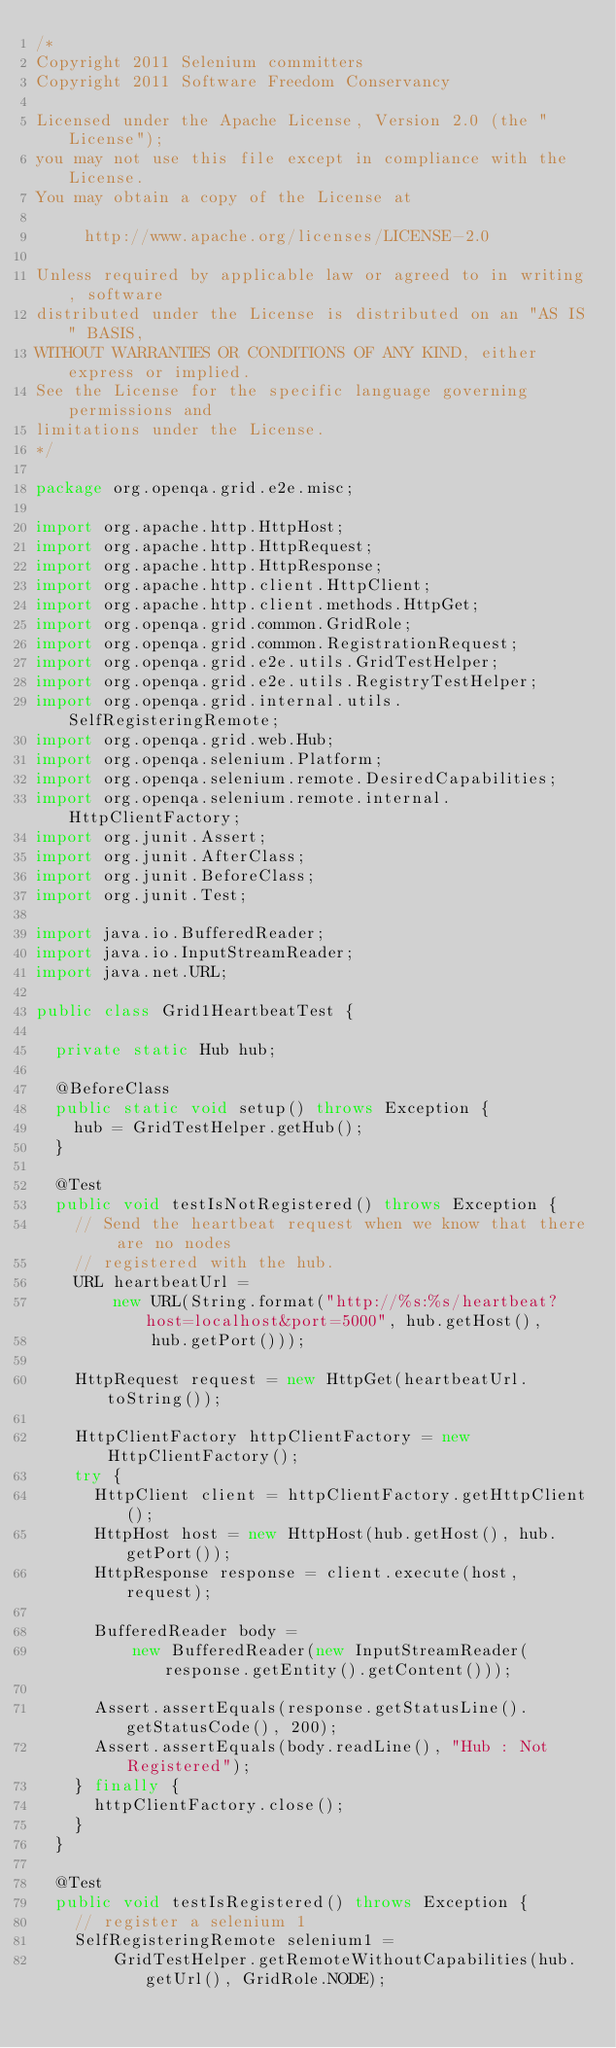Convert code to text. <code><loc_0><loc_0><loc_500><loc_500><_Java_>/*
Copyright 2011 Selenium committers
Copyright 2011 Software Freedom Conservancy

Licensed under the Apache License, Version 2.0 (the "License");
you may not use this file except in compliance with the License.
You may obtain a copy of the License at

     http://www.apache.org/licenses/LICENSE-2.0

Unless required by applicable law or agreed to in writing, software
distributed under the License is distributed on an "AS IS" BASIS,
WITHOUT WARRANTIES OR CONDITIONS OF ANY KIND, either express or implied.
See the License for the specific language governing permissions and
limitations under the License.
*/

package org.openqa.grid.e2e.misc;

import org.apache.http.HttpHost;
import org.apache.http.HttpRequest;
import org.apache.http.HttpResponse;
import org.apache.http.client.HttpClient;
import org.apache.http.client.methods.HttpGet;
import org.openqa.grid.common.GridRole;
import org.openqa.grid.common.RegistrationRequest;
import org.openqa.grid.e2e.utils.GridTestHelper;
import org.openqa.grid.e2e.utils.RegistryTestHelper;
import org.openqa.grid.internal.utils.SelfRegisteringRemote;
import org.openqa.grid.web.Hub;
import org.openqa.selenium.Platform;
import org.openqa.selenium.remote.DesiredCapabilities;
import org.openqa.selenium.remote.internal.HttpClientFactory;
import org.junit.Assert;
import org.junit.AfterClass;
import org.junit.BeforeClass;
import org.junit.Test;

import java.io.BufferedReader;
import java.io.InputStreamReader;
import java.net.URL;

public class Grid1HeartbeatTest {

  private static Hub hub;

  @BeforeClass
  public static void setup() throws Exception {
    hub = GridTestHelper.getHub();
  }

  @Test
  public void testIsNotRegistered() throws Exception {
    // Send the heartbeat request when we know that there are no nodes
    // registered with the hub.
    URL heartbeatUrl =
        new URL(String.format("http://%s:%s/heartbeat?host=localhost&port=5000", hub.getHost(),
            hub.getPort()));

    HttpRequest request = new HttpGet(heartbeatUrl.toString());

    HttpClientFactory httpClientFactory = new HttpClientFactory();
    try {
      HttpClient client = httpClientFactory.getHttpClient();
      HttpHost host = new HttpHost(hub.getHost(), hub.getPort());
      HttpResponse response = client.execute(host, request);

      BufferedReader body =
          new BufferedReader(new InputStreamReader(response.getEntity().getContent()));

      Assert.assertEquals(response.getStatusLine().getStatusCode(), 200);
      Assert.assertEquals(body.readLine(), "Hub : Not Registered");
    } finally {
      httpClientFactory.close();
    }
  }

  @Test
  public void testIsRegistered() throws Exception {
    // register a selenium 1
    SelfRegisteringRemote selenium1 =
        GridTestHelper.getRemoteWithoutCapabilities(hub.getUrl(), GridRole.NODE);</code> 